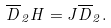<formula> <loc_0><loc_0><loc_500><loc_500>\overline { D } _ { 2 } H = J \overline { D } _ { 2 } .</formula> 